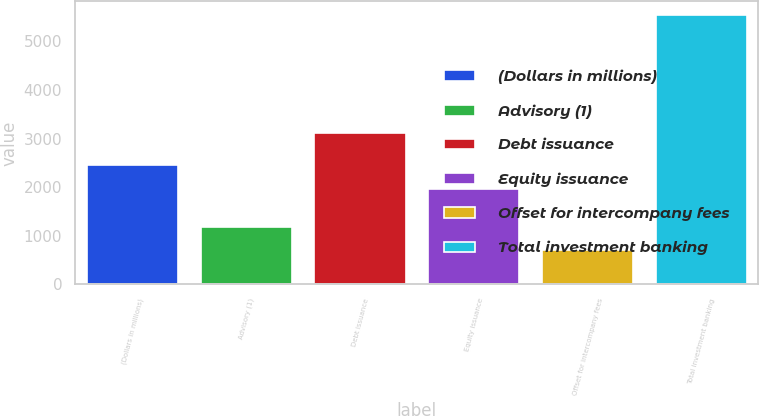Convert chart to OTSL. <chart><loc_0><loc_0><loc_500><loc_500><bar_chart><fcel>(Dollars in millions)<fcel>Advisory (1)<fcel>Debt issuance<fcel>Equity issuance<fcel>Offset for intercompany fees<fcel>Total investment banking<nl><fcel>2448.7<fcel>1188.7<fcel>3124<fcel>1964<fcel>704<fcel>5551<nl></chart> 